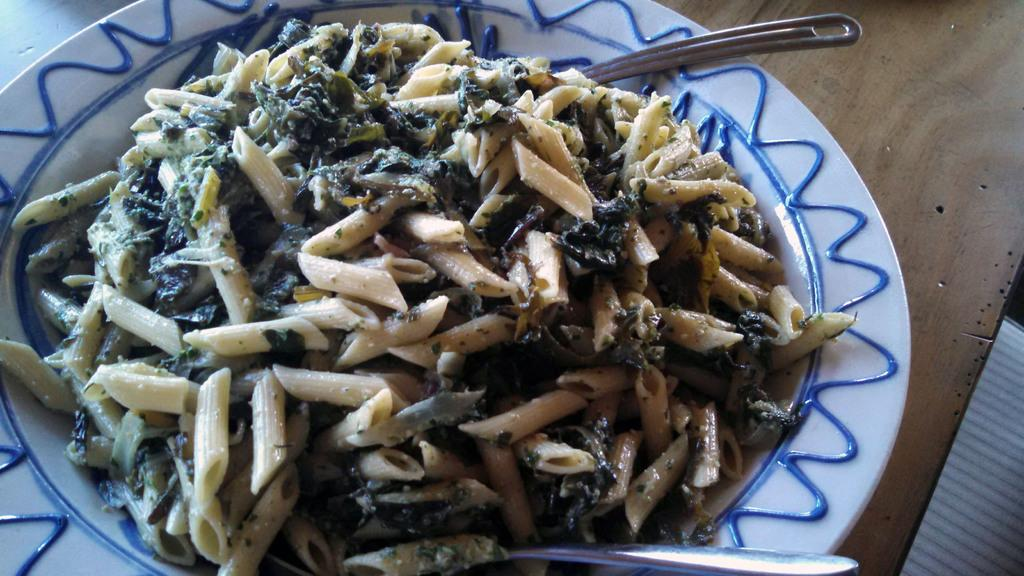What type of food is in the foreground of the image? There is pasta in the foreground of the image. What utensils are present on the platter in the foreground? There are two spoons on a platter in the foreground. What is the surface on which the platter is placed? The platter is placed on a wooden surface. What type of pear is sitting on the wooden surface in the image? There is no pear present in the image; it features pasta and spoons on a platter. 